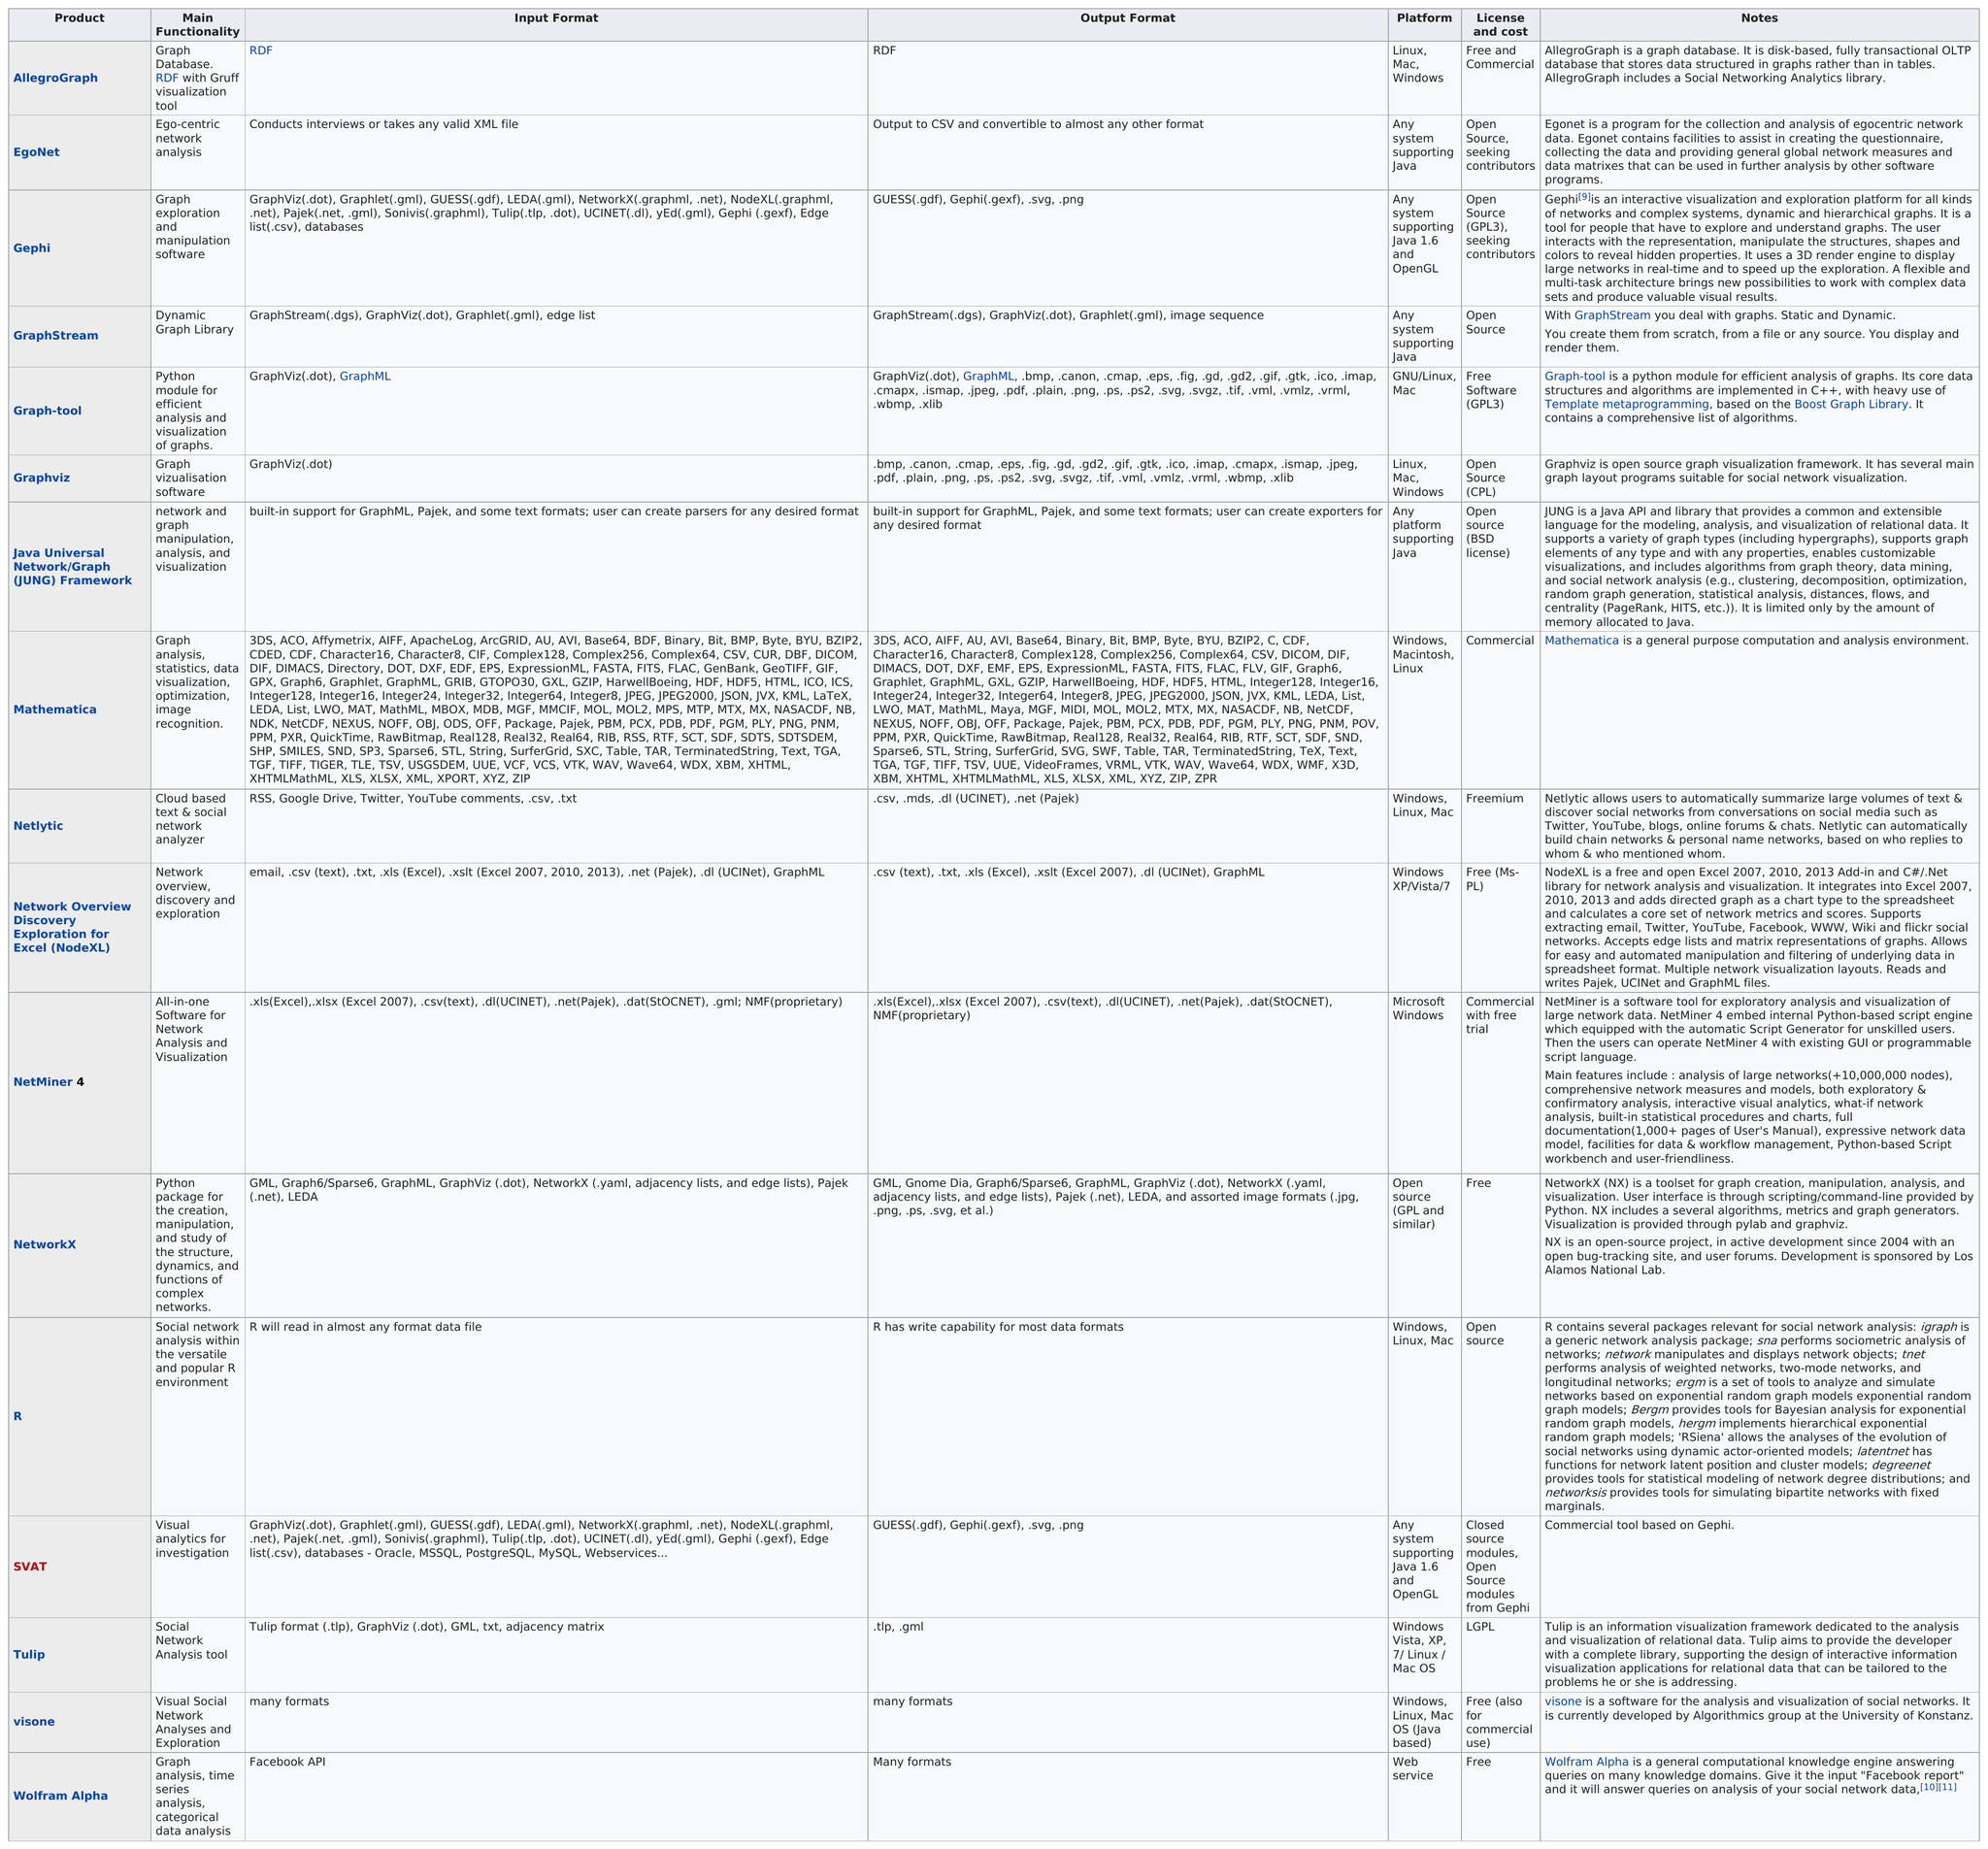Indicate a few pertinent items in this graphic. Gephi is the next product listed after Egonet. There are 7 open source products available. The total number of products represented in the chart is 17. Graphstream and Egonet are software platforms that can run on any system that supports Java, and are not limited to any specific operating system. After using Graph-Tool, the next step in creating visual representations of graphs is Graphviz. 